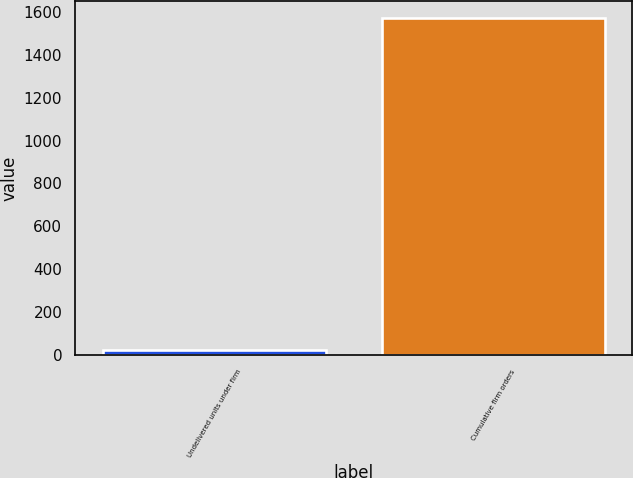Convert chart. <chart><loc_0><loc_0><loc_500><loc_500><bar_chart><fcel>Undelivered units under firm<fcel>Cumulative firm orders<nl><fcel>24<fcel>1572<nl></chart> 